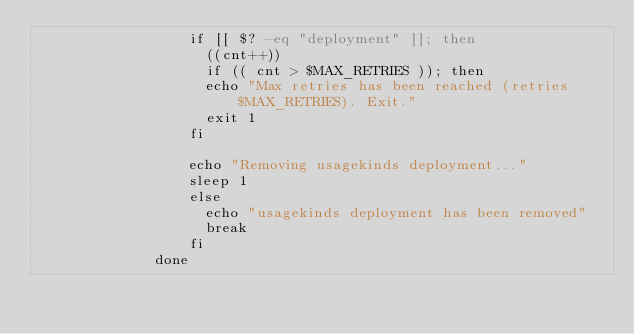<code> <loc_0><loc_0><loc_500><loc_500><_YAML_>                  if [[ $? -eq "deployment" ]]; then
                    ((cnt++))
                    if (( cnt > $MAX_RETRIES )); then
                    echo "Max retries has been reached (retries $MAX_RETRIES). Exit."
                    exit 1
                  fi

                  echo "Removing usagekinds deployment..."
                  sleep 1
                  else
                    echo "usagekinds deployment has been removed"
                    break
                  fi
              done
</code> 